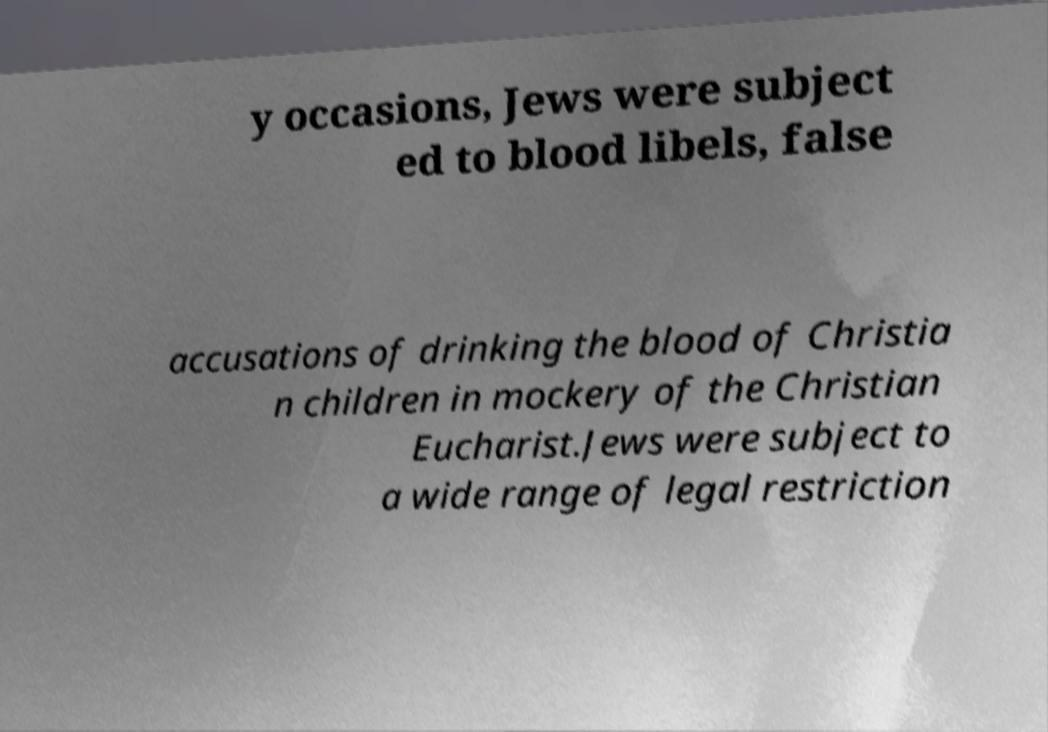Please identify and transcribe the text found in this image. y occasions, Jews were subject ed to blood libels, false accusations of drinking the blood of Christia n children in mockery of the Christian Eucharist.Jews were subject to a wide range of legal restriction 